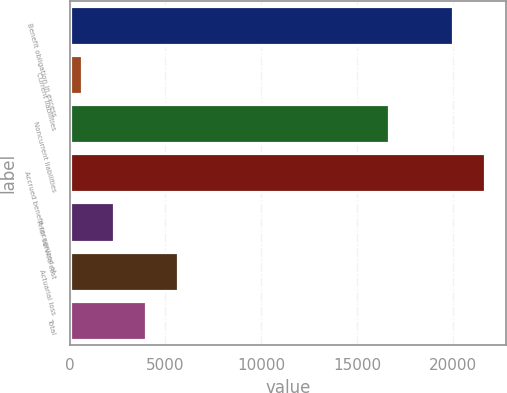Convert chart to OTSL. <chart><loc_0><loc_0><loc_500><loc_500><bar_chart><fcel>Benefit obligation in excess<fcel>Current liabilities<fcel>Noncurrent liabilities<fcel>Accrued benefit recognized at<fcel>Prior service cost<fcel>Actuarial loss<fcel>Total<nl><fcel>19988.4<fcel>643<fcel>16657<fcel>21654.1<fcel>2308.7<fcel>5640.1<fcel>3974.4<nl></chart> 